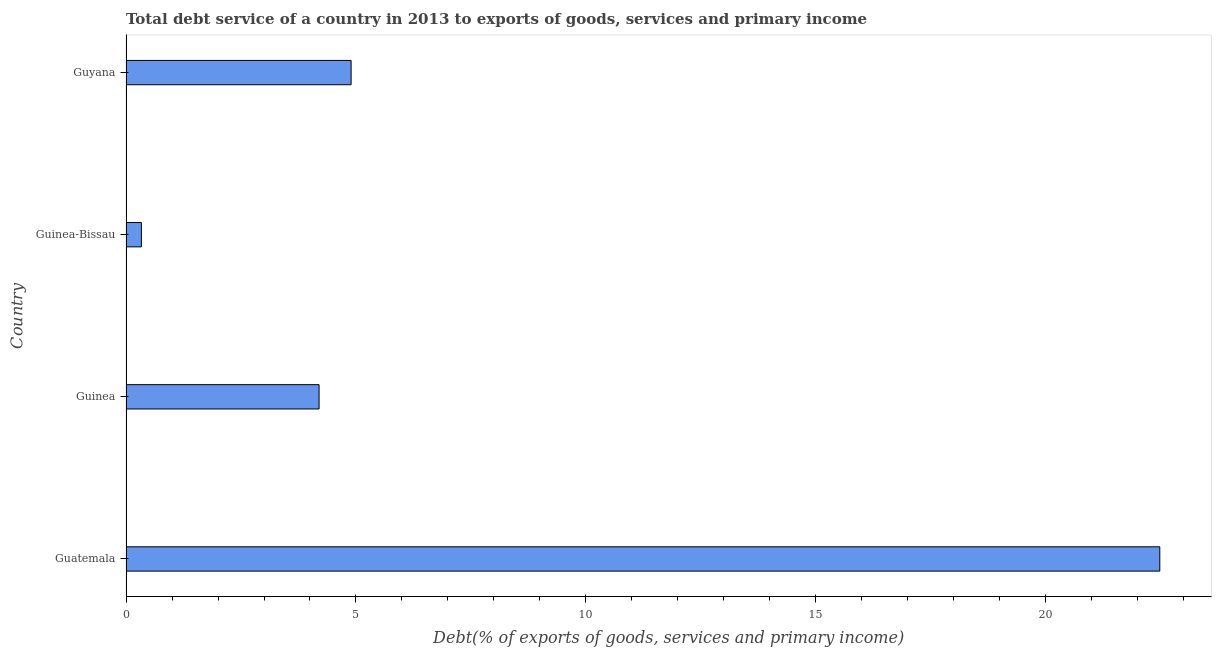Does the graph contain grids?
Offer a very short reply. No. What is the title of the graph?
Offer a terse response. Total debt service of a country in 2013 to exports of goods, services and primary income. What is the label or title of the X-axis?
Make the answer very short. Debt(% of exports of goods, services and primary income). What is the label or title of the Y-axis?
Provide a short and direct response. Country. What is the total debt service in Guatemala?
Provide a succinct answer. 22.48. Across all countries, what is the maximum total debt service?
Provide a succinct answer. 22.48. Across all countries, what is the minimum total debt service?
Provide a succinct answer. 0.33. In which country was the total debt service maximum?
Give a very brief answer. Guatemala. In which country was the total debt service minimum?
Your answer should be compact. Guinea-Bissau. What is the sum of the total debt service?
Give a very brief answer. 31.9. What is the difference between the total debt service in Guinea-Bissau and Guyana?
Your answer should be very brief. -4.56. What is the average total debt service per country?
Give a very brief answer. 7.98. What is the median total debt service?
Your answer should be compact. 4.55. In how many countries, is the total debt service greater than 11 %?
Ensure brevity in your answer.  1. What is the ratio of the total debt service in Guinea to that in Guinea-Bissau?
Make the answer very short. 12.56. Is the total debt service in Guinea less than that in Guinea-Bissau?
Your answer should be compact. No. Is the difference between the total debt service in Guinea and Guinea-Bissau greater than the difference between any two countries?
Keep it short and to the point. No. What is the difference between the highest and the second highest total debt service?
Provide a short and direct response. 17.58. What is the difference between the highest and the lowest total debt service?
Provide a succinct answer. 22.14. In how many countries, is the total debt service greater than the average total debt service taken over all countries?
Your answer should be compact. 1. How many bars are there?
Ensure brevity in your answer.  4. Are all the bars in the graph horizontal?
Ensure brevity in your answer.  Yes. What is the difference between two consecutive major ticks on the X-axis?
Ensure brevity in your answer.  5. What is the Debt(% of exports of goods, services and primary income) of Guatemala?
Give a very brief answer. 22.48. What is the Debt(% of exports of goods, services and primary income) in Guinea?
Provide a succinct answer. 4.2. What is the Debt(% of exports of goods, services and primary income) in Guinea-Bissau?
Give a very brief answer. 0.33. What is the Debt(% of exports of goods, services and primary income) in Guyana?
Give a very brief answer. 4.89. What is the difference between the Debt(% of exports of goods, services and primary income) in Guatemala and Guinea?
Offer a terse response. 18.28. What is the difference between the Debt(% of exports of goods, services and primary income) in Guatemala and Guinea-Bissau?
Keep it short and to the point. 22.14. What is the difference between the Debt(% of exports of goods, services and primary income) in Guatemala and Guyana?
Give a very brief answer. 17.58. What is the difference between the Debt(% of exports of goods, services and primary income) in Guinea and Guinea-Bissau?
Your answer should be very brief. 3.86. What is the difference between the Debt(% of exports of goods, services and primary income) in Guinea and Guyana?
Keep it short and to the point. -0.7. What is the difference between the Debt(% of exports of goods, services and primary income) in Guinea-Bissau and Guyana?
Give a very brief answer. -4.56. What is the ratio of the Debt(% of exports of goods, services and primary income) in Guatemala to that in Guinea?
Give a very brief answer. 5.36. What is the ratio of the Debt(% of exports of goods, services and primary income) in Guatemala to that in Guinea-Bissau?
Your answer should be compact. 67.26. What is the ratio of the Debt(% of exports of goods, services and primary income) in Guatemala to that in Guyana?
Make the answer very short. 4.59. What is the ratio of the Debt(% of exports of goods, services and primary income) in Guinea to that in Guinea-Bissau?
Your answer should be very brief. 12.56. What is the ratio of the Debt(% of exports of goods, services and primary income) in Guinea to that in Guyana?
Your response must be concise. 0.86. What is the ratio of the Debt(% of exports of goods, services and primary income) in Guinea-Bissau to that in Guyana?
Your answer should be very brief. 0.07. 